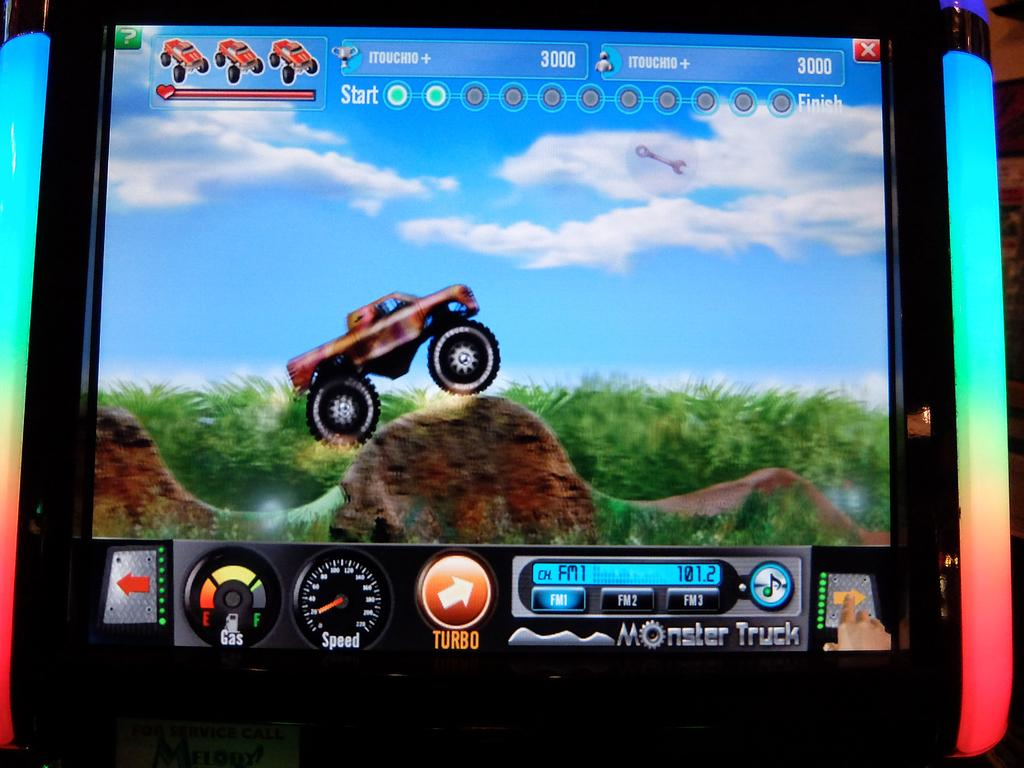What is the main subject of the image? The main subject of the image is a vehicle on a rock. What type of natural environment is visible in the image? There is grass and plants visible in the image. What feature of the vehicle can be seen in the image? A speed meter is visible in the image. Can you describe the surroundings of the vehicle? There are other unspecified things around the screen, but their nature is not clear from the provided facts. What advice is the vehicle giving to the plants in the image? There is no indication in the image that the vehicle is giving advice to the plants, as vehicles do not have the ability to communicate or provide advice. 